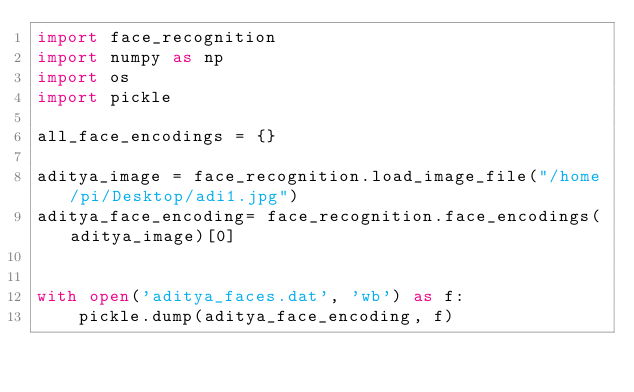Convert code to text. <code><loc_0><loc_0><loc_500><loc_500><_Python_>import face_recognition
import numpy as np
import os
import pickle

all_face_encodings = {}

aditya_image = face_recognition.load_image_file("/home/pi/Desktop/adi1.jpg")
aditya_face_encoding= face_recognition.face_encodings(aditya_image)[0]


with open('aditya_faces.dat', 'wb') as f:
    pickle.dump(aditya_face_encoding, f)</code> 